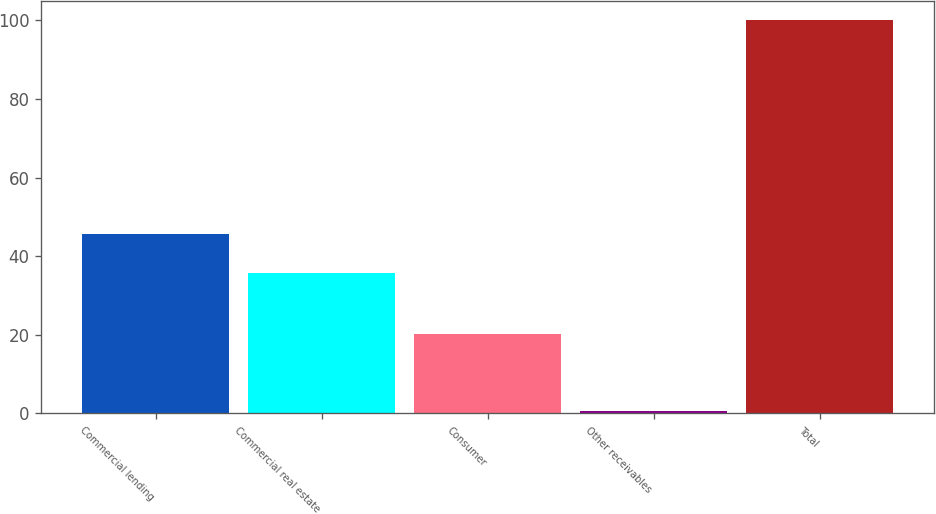<chart> <loc_0><loc_0><loc_500><loc_500><bar_chart><fcel>Commercial lending<fcel>Commercial real estate<fcel>Consumer<fcel>Other receivables<fcel>Total<nl><fcel>45.74<fcel>35.8<fcel>20.1<fcel>0.6<fcel>100<nl></chart> 